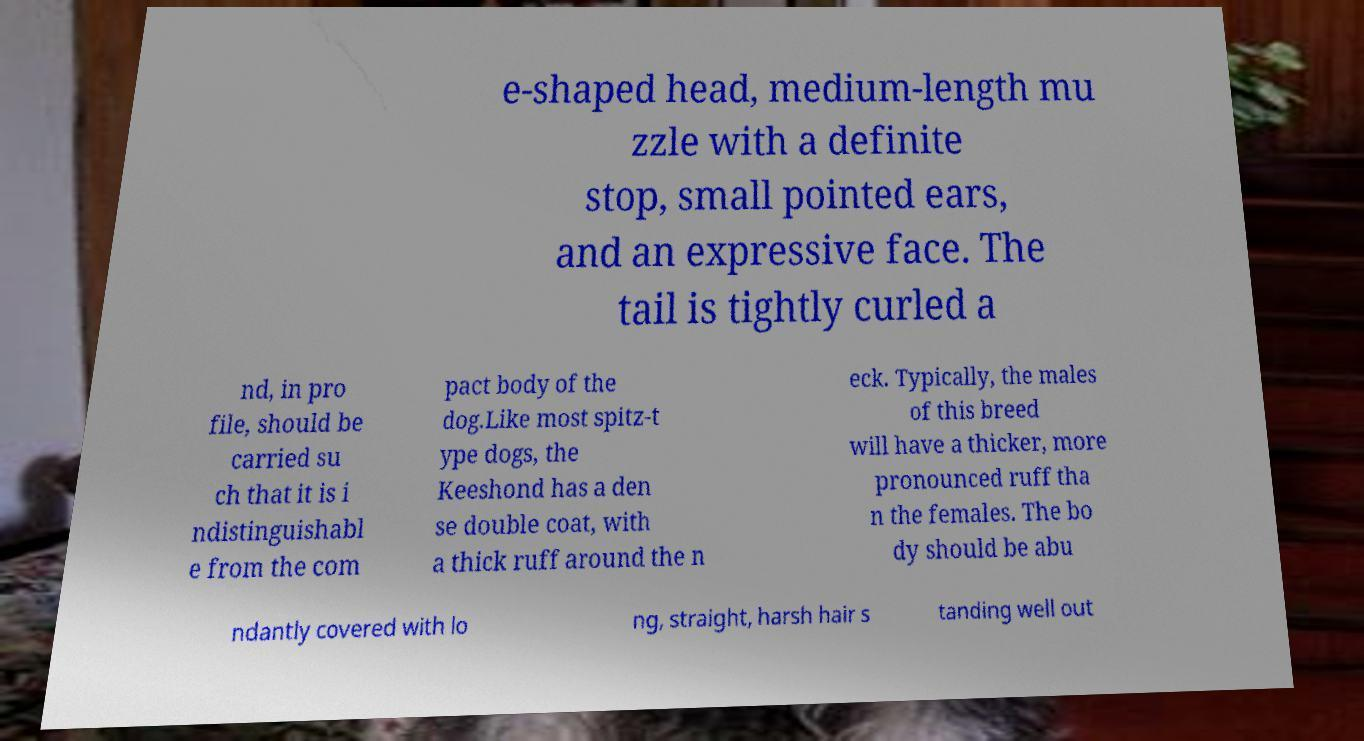Can you accurately transcribe the text from the provided image for me? e-shaped head, medium-length mu zzle with a definite stop, small pointed ears, and an expressive face. The tail is tightly curled a nd, in pro file, should be carried su ch that it is i ndistinguishabl e from the com pact body of the dog.Like most spitz-t ype dogs, the Keeshond has a den se double coat, with a thick ruff around the n eck. Typically, the males of this breed will have a thicker, more pronounced ruff tha n the females. The bo dy should be abu ndantly covered with lo ng, straight, harsh hair s tanding well out 